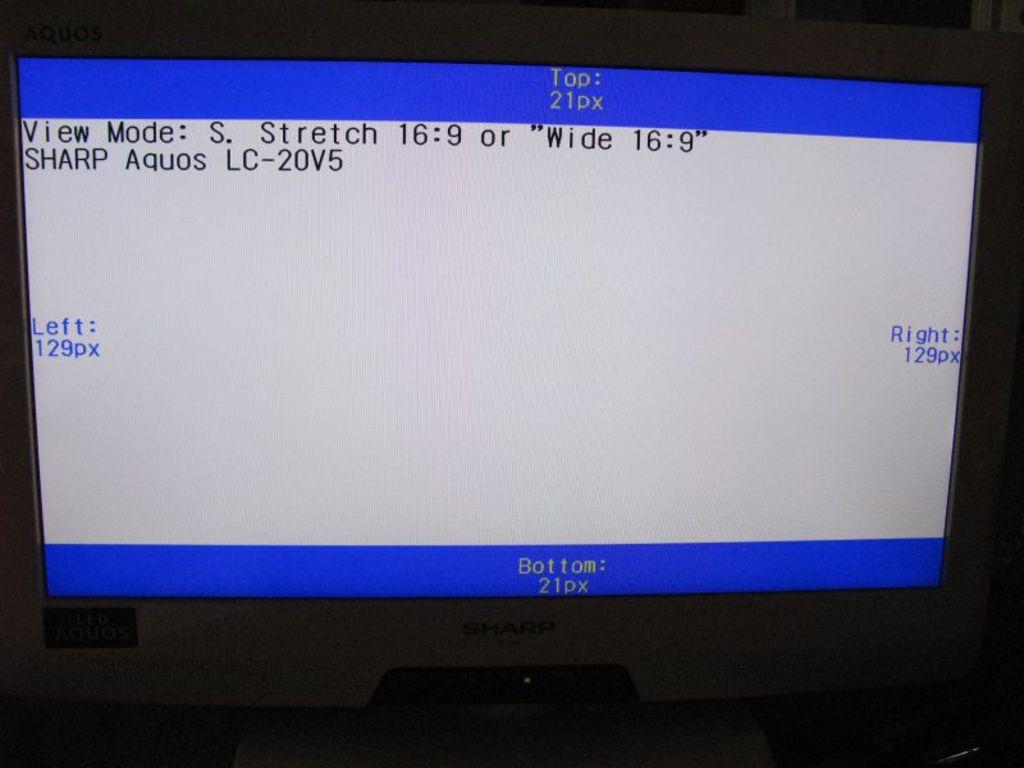Provide a one-sentence caption for the provided image. The view mode of a Sharp Aquos LC-20V5 shows the display properties. 